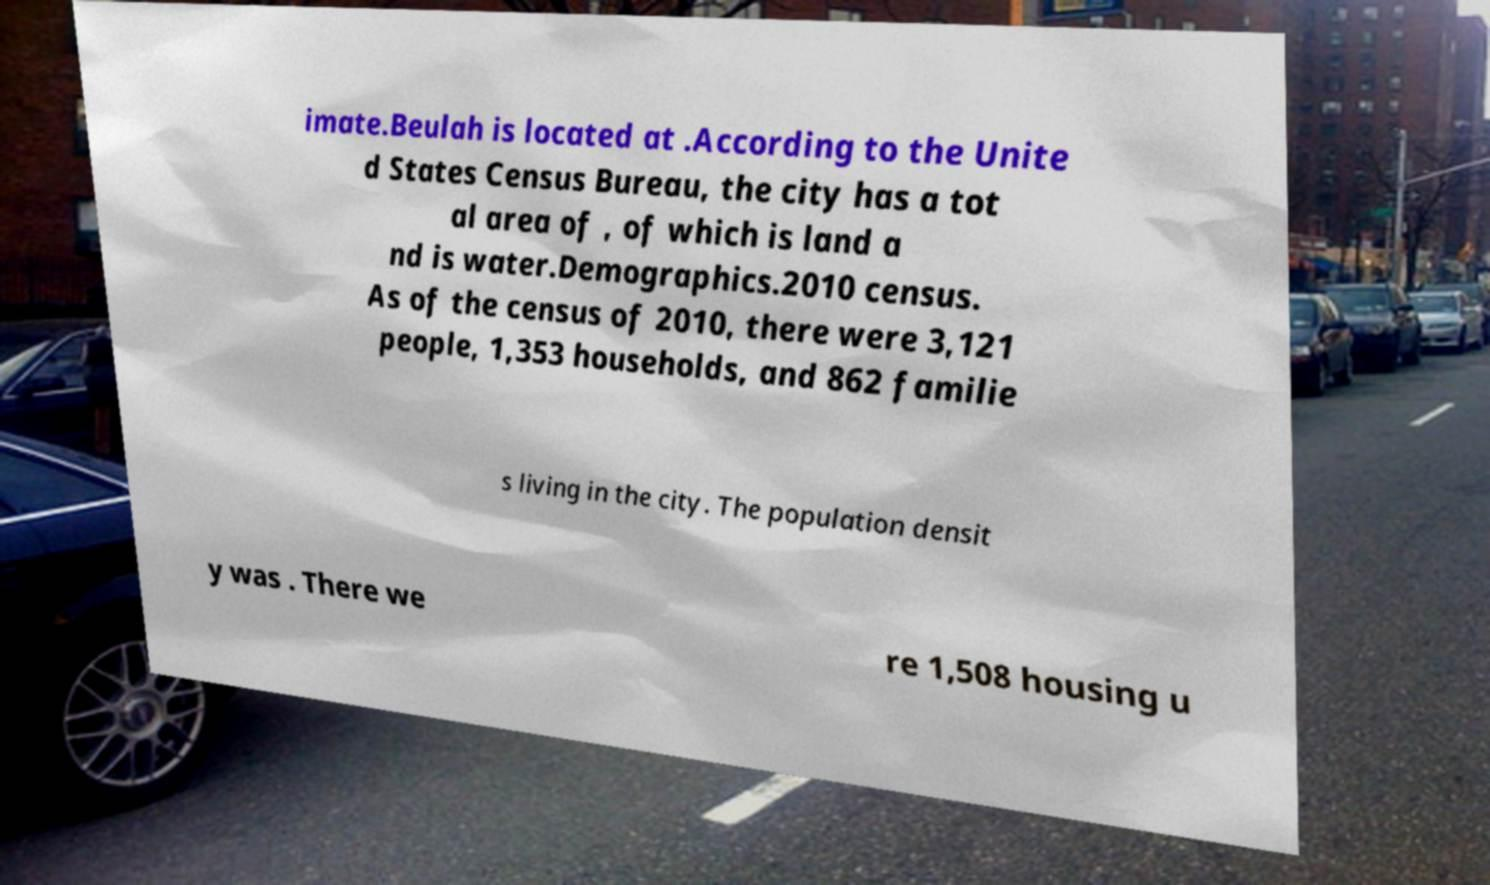I need the written content from this picture converted into text. Can you do that? imate.Beulah is located at .According to the Unite d States Census Bureau, the city has a tot al area of , of which is land a nd is water.Demographics.2010 census. As of the census of 2010, there were 3,121 people, 1,353 households, and 862 familie s living in the city. The population densit y was . There we re 1,508 housing u 